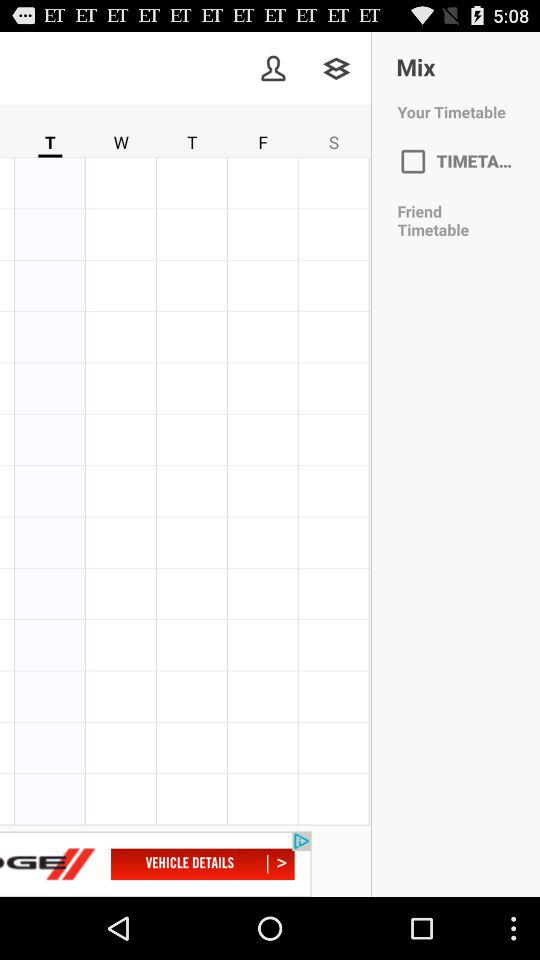How many days are displayed in the timetable?
Answer the question using a single word or phrase. 5 